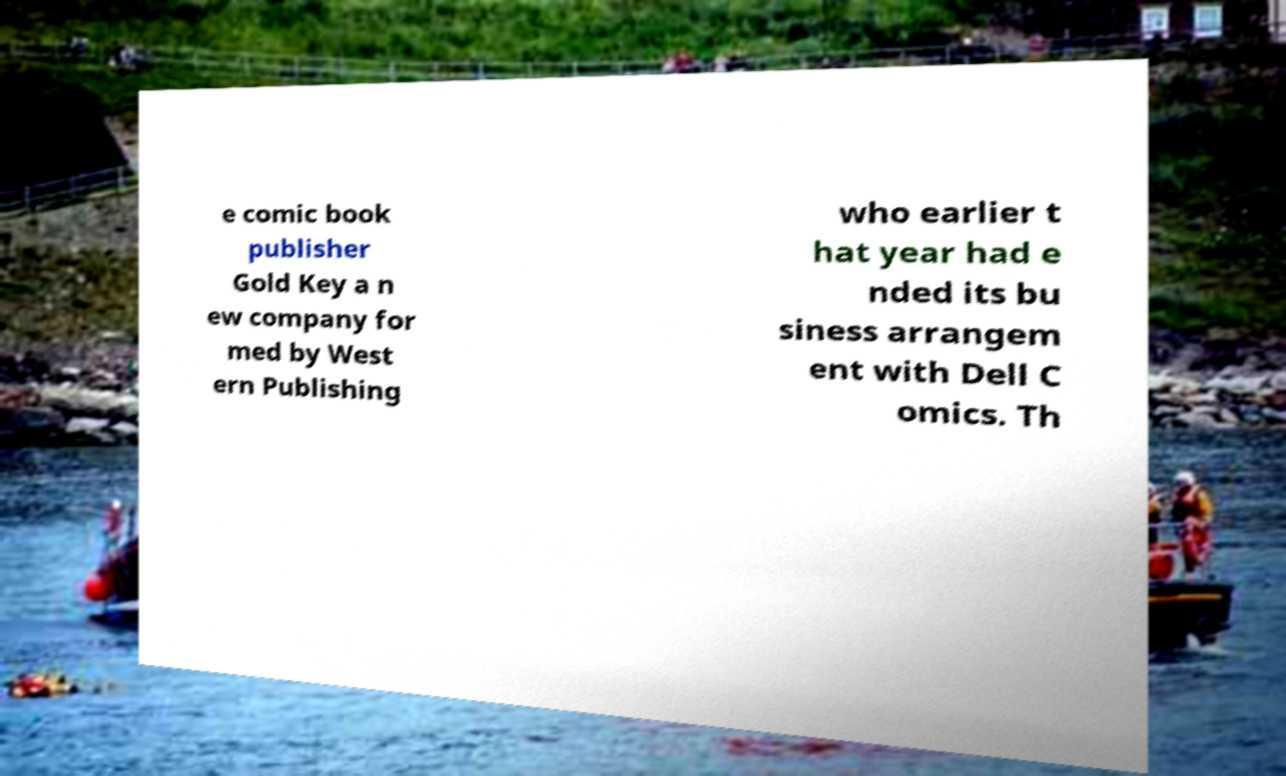What messages or text are displayed in this image? I need them in a readable, typed format. e comic book publisher Gold Key a n ew company for med by West ern Publishing who earlier t hat year had e nded its bu siness arrangem ent with Dell C omics. Th 